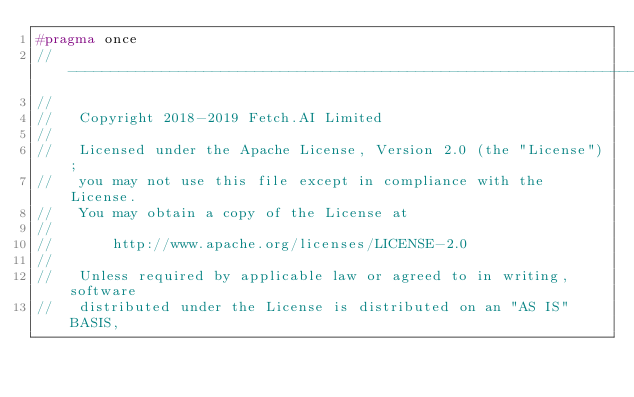<code> <loc_0><loc_0><loc_500><loc_500><_C++_>#pragma once
//------------------------------------------------------------------------------
//
//   Copyright 2018-2019 Fetch.AI Limited
//
//   Licensed under the Apache License, Version 2.0 (the "License");
//   you may not use this file except in compliance with the License.
//   You may obtain a copy of the License at
//
//       http://www.apache.org/licenses/LICENSE-2.0
//
//   Unless required by applicable law or agreed to in writing, software
//   distributed under the License is distributed on an "AS IS" BASIS,</code> 